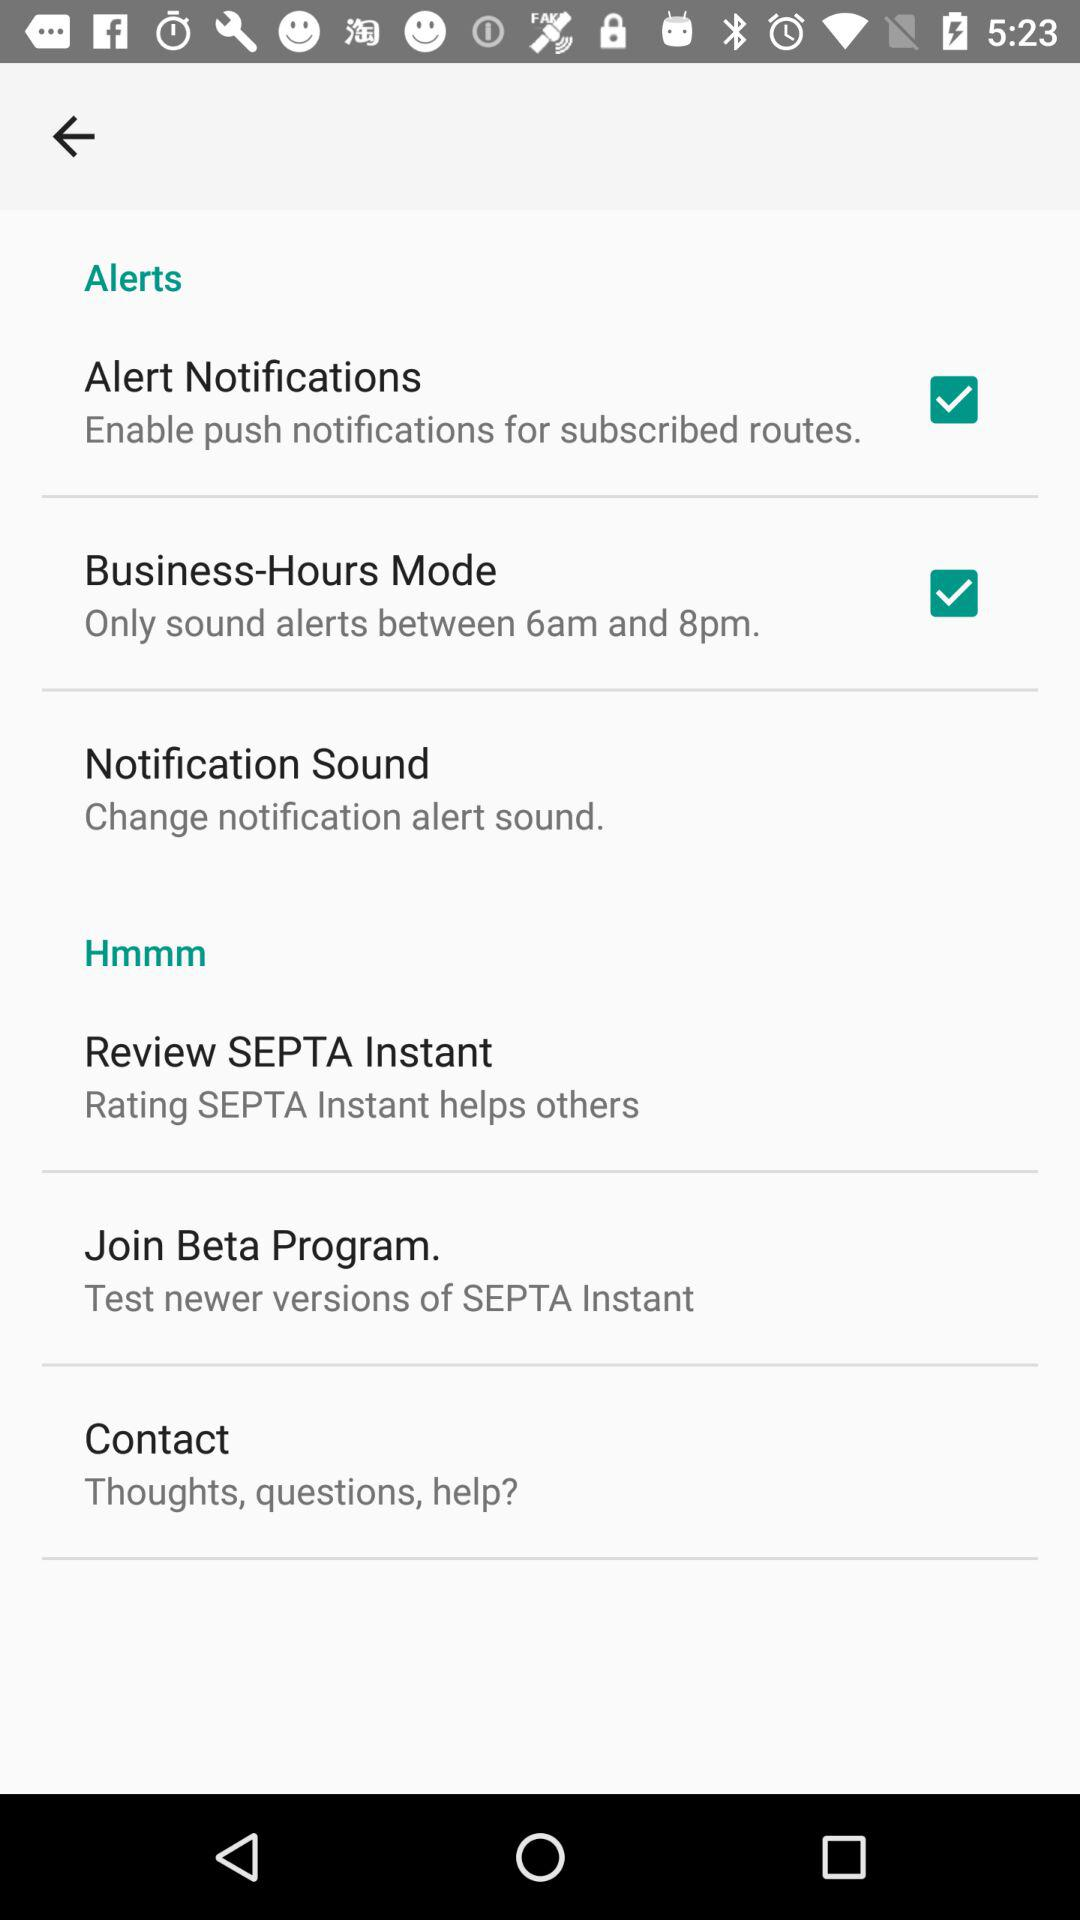How many items have a checkbox in the Alerts settings screen?
Answer the question using a single word or phrase. 2 